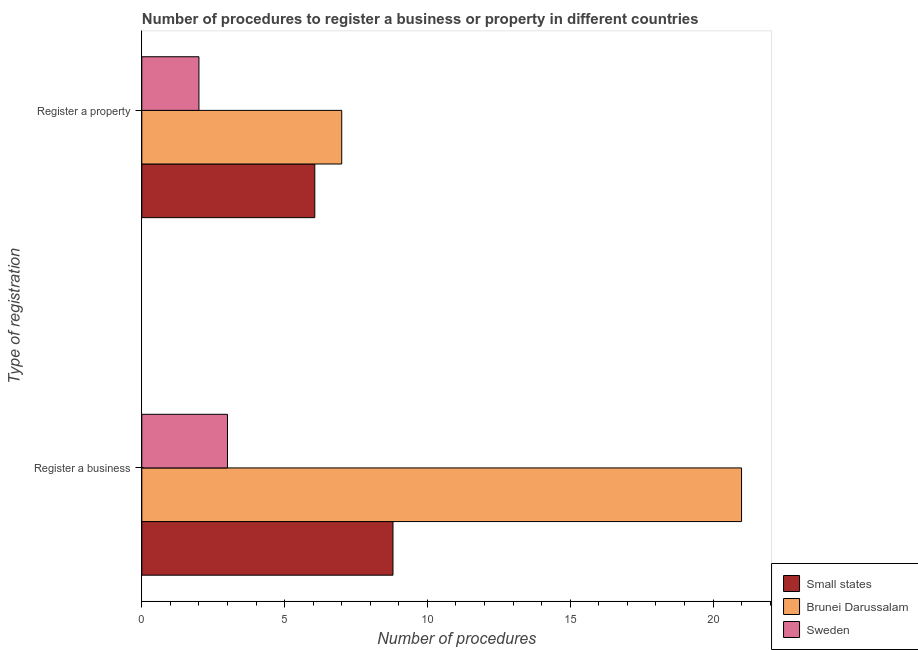How many groups of bars are there?
Offer a very short reply. 2. Are the number of bars on each tick of the Y-axis equal?
Ensure brevity in your answer.  Yes. What is the label of the 1st group of bars from the top?
Ensure brevity in your answer.  Register a property. What is the number of procedures to register a business in Brunei Darussalam?
Provide a succinct answer. 21. Across all countries, what is the maximum number of procedures to register a business?
Offer a very short reply. 21. Across all countries, what is the minimum number of procedures to register a property?
Ensure brevity in your answer.  2. In which country was the number of procedures to register a business maximum?
Give a very brief answer. Brunei Darussalam. In which country was the number of procedures to register a property minimum?
Your answer should be very brief. Sweden. What is the total number of procedures to register a property in the graph?
Offer a terse response. 15.06. What is the difference between the number of procedures to register a business in Sweden and that in Brunei Darussalam?
Your answer should be compact. -18. What is the difference between the number of procedures to register a business in Brunei Darussalam and the number of procedures to register a property in Sweden?
Your response must be concise. 19. What is the average number of procedures to register a property per country?
Make the answer very short. 5.02. What is the difference between the number of procedures to register a business and number of procedures to register a property in Sweden?
Your answer should be compact. 1. What is the ratio of the number of procedures to register a business in Brunei Darussalam to that in Sweden?
Make the answer very short. 7. In how many countries, is the number of procedures to register a property greater than the average number of procedures to register a property taken over all countries?
Offer a very short reply. 2. What does the 2nd bar from the top in Register a business represents?
Offer a terse response. Brunei Darussalam. What does the 1st bar from the bottom in Register a business represents?
Offer a terse response. Small states. What is the difference between two consecutive major ticks on the X-axis?
Ensure brevity in your answer.  5. Does the graph contain grids?
Keep it short and to the point. No. How many legend labels are there?
Ensure brevity in your answer.  3. What is the title of the graph?
Ensure brevity in your answer.  Number of procedures to register a business or property in different countries. Does "Israel" appear as one of the legend labels in the graph?
Provide a short and direct response. No. What is the label or title of the X-axis?
Give a very brief answer. Number of procedures. What is the label or title of the Y-axis?
Ensure brevity in your answer.  Type of registration. What is the Number of procedures of Small states in Register a business?
Make the answer very short. 8.79. What is the Number of procedures of Brunei Darussalam in Register a business?
Keep it short and to the point. 21. What is the Number of procedures in Sweden in Register a business?
Make the answer very short. 3. What is the Number of procedures in Small states in Register a property?
Your answer should be very brief. 6.06. What is the Number of procedures of Brunei Darussalam in Register a property?
Make the answer very short. 7. Across all Type of registration, what is the maximum Number of procedures in Small states?
Your answer should be very brief. 8.79. Across all Type of registration, what is the minimum Number of procedures in Small states?
Offer a terse response. 6.06. Across all Type of registration, what is the minimum Number of procedures in Brunei Darussalam?
Keep it short and to the point. 7. What is the total Number of procedures in Small states in the graph?
Keep it short and to the point. 14.85. What is the difference between the Number of procedures in Small states in Register a business and that in Register a property?
Keep it short and to the point. 2.74. What is the difference between the Number of procedures of Brunei Darussalam in Register a business and that in Register a property?
Keep it short and to the point. 14. What is the difference between the Number of procedures of Small states in Register a business and the Number of procedures of Brunei Darussalam in Register a property?
Make the answer very short. 1.79. What is the difference between the Number of procedures of Small states in Register a business and the Number of procedures of Sweden in Register a property?
Your answer should be very brief. 6.79. What is the difference between the Number of procedures of Brunei Darussalam in Register a business and the Number of procedures of Sweden in Register a property?
Your answer should be very brief. 19. What is the average Number of procedures of Small states per Type of registration?
Give a very brief answer. 7.43. What is the average Number of procedures in Brunei Darussalam per Type of registration?
Provide a succinct answer. 14. What is the difference between the Number of procedures of Small states and Number of procedures of Brunei Darussalam in Register a business?
Your answer should be compact. -12.21. What is the difference between the Number of procedures of Small states and Number of procedures of Sweden in Register a business?
Give a very brief answer. 5.79. What is the difference between the Number of procedures of Small states and Number of procedures of Brunei Darussalam in Register a property?
Offer a terse response. -0.94. What is the difference between the Number of procedures in Small states and Number of procedures in Sweden in Register a property?
Offer a terse response. 4.06. What is the difference between the Number of procedures of Brunei Darussalam and Number of procedures of Sweden in Register a property?
Offer a terse response. 5. What is the ratio of the Number of procedures of Small states in Register a business to that in Register a property?
Your response must be concise. 1.45. What is the difference between the highest and the second highest Number of procedures in Small states?
Give a very brief answer. 2.74. What is the difference between the highest and the lowest Number of procedures in Small states?
Keep it short and to the point. 2.74. What is the difference between the highest and the lowest Number of procedures in Brunei Darussalam?
Offer a terse response. 14. What is the difference between the highest and the lowest Number of procedures of Sweden?
Provide a succinct answer. 1. 